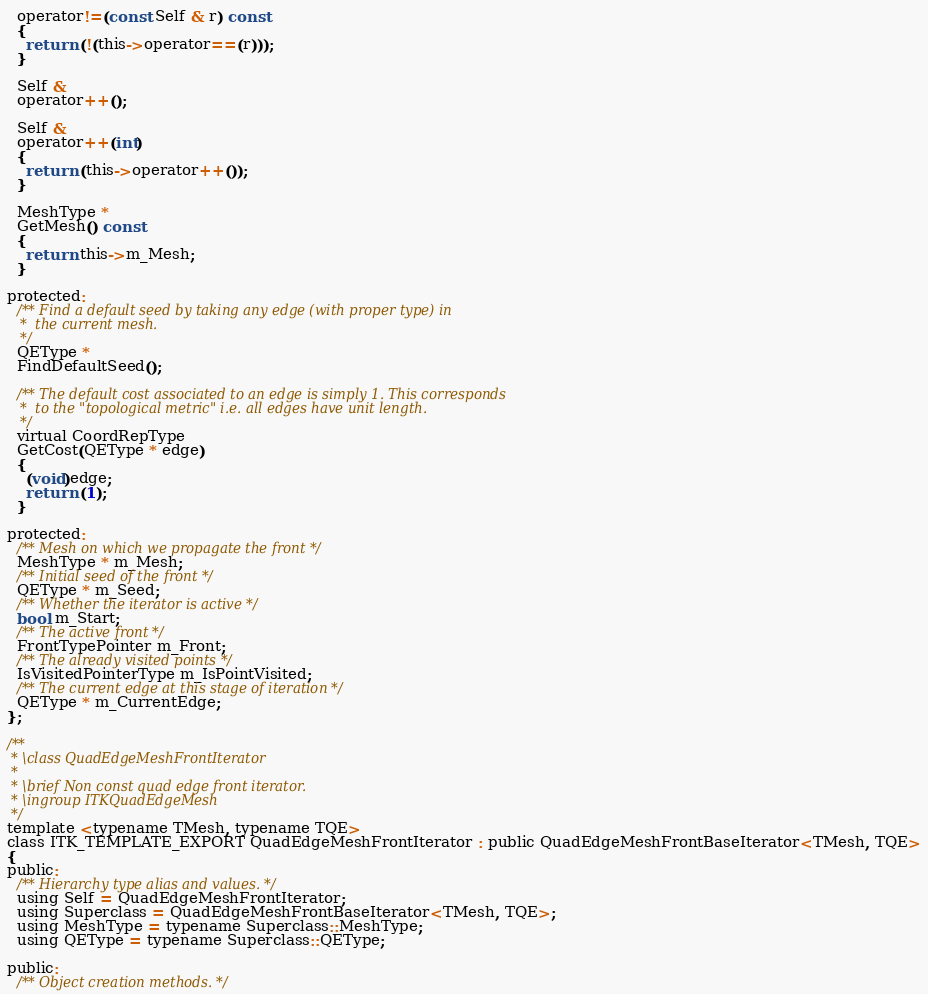<code> <loc_0><loc_0><loc_500><loc_500><_C_>  operator!=(const Self & r) const
  {
    return (!(this->operator==(r)));
  }

  Self &
  operator++();

  Self &
  operator++(int)
  {
    return (this->operator++());
  }

  MeshType *
  GetMesh() const
  {
    return this->m_Mesh;
  }

protected:
  /** Find a default seed by taking any edge (with proper type) in
   *  the current mesh.
   */
  QEType *
  FindDefaultSeed();

  /** The default cost associated to an edge is simply 1. This corresponds
   *  to the "topological metric" i.e. all edges have unit length.
   */
  virtual CoordRepType
  GetCost(QEType * edge)
  {
    (void)edge;
    return (1);
  }

protected:
  /** Mesh on which we propagate the front */
  MeshType * m_Mesh;
  /** Initial seed of the front */
  QEType * m_Seed;
  /** Whether the iterator is active */
  bool m_Start;
  /** The active front */
  FrontTypePointer m_Front;
  /** The already visited points */
  IsVisitedPointerType m_IsPointVisited;
  /** The current edge at this stage of iteration */
  QEType * m_CurrentEdge;
};

/**
 * \class QuadEdgeMeshFrontIterator
 *
 * \brief Non const quad edge front iterator.
 * \ingroup ITKQuadEdgeMesh
 */
template <typename TMesh, typename TQE>
class ITK_TEMPLATE_EXPORT QuadEdgeMeshFrontIterator : public QuadEdgeMeshFrontBaseIterator<TMesh, TQE>
{
public:
  /** Hierarchy type alias and values. */
  using Self = QuadEdgeMeshFrontIterator;
  using Superclass = QuadEdgeMeshFrontBaseIterator<TMesh, TQE>;
  using MeshType = typename Superclass::MeshType;
  using QEType = typename Superclass::QEType;

public:
  /** Object creation methods. */</code> 